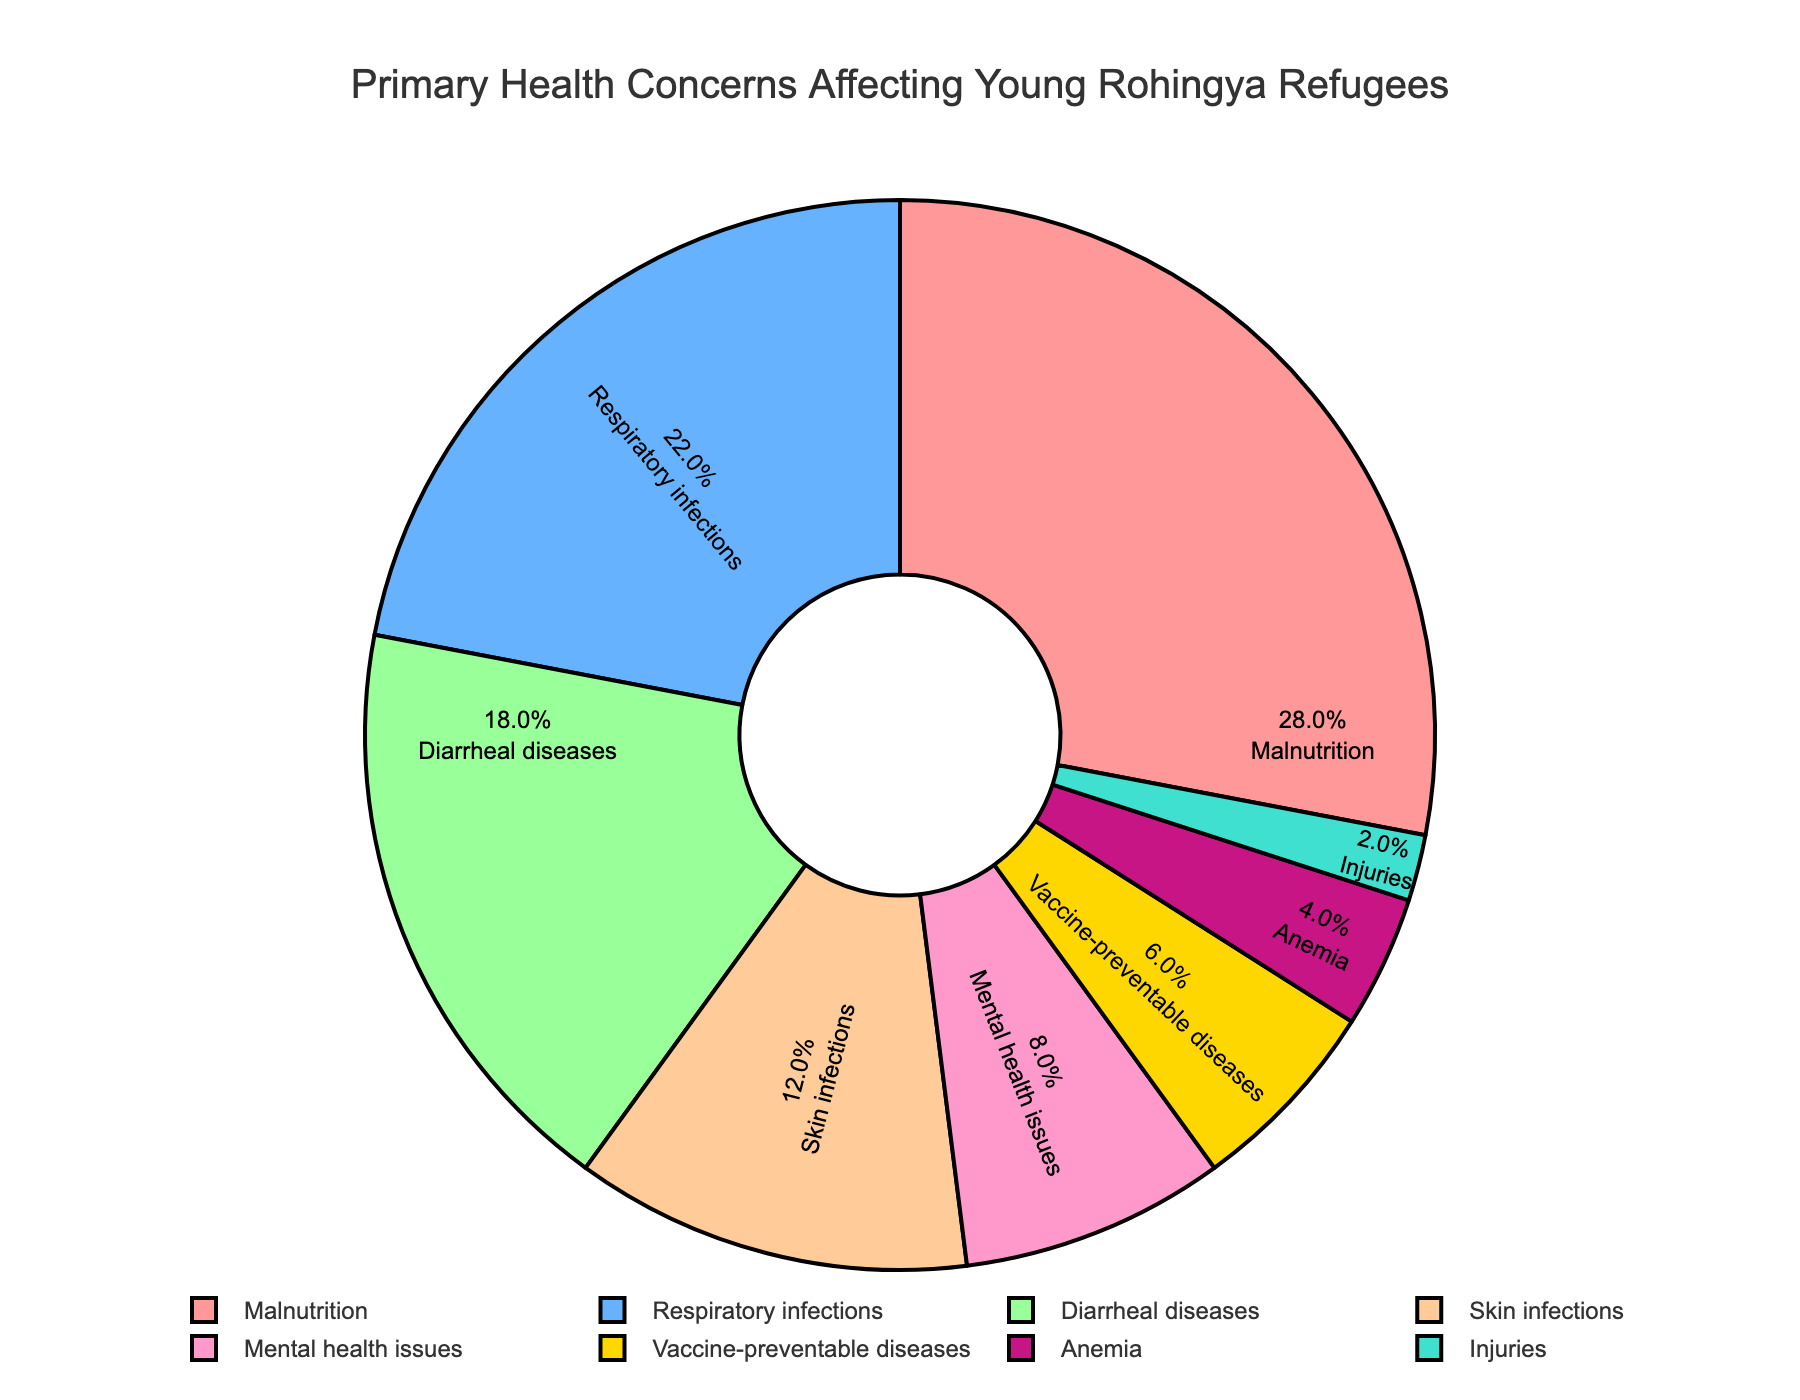What is the most common health concern affecting young Rohingya refugees? To find the most common health concern, look for the largest percentage slice in the pie chart. The 'Malnutrition' slice is the largest at 28%.
Answer: Malnutrition How does the percentage of respiratory infections compare to vaccine-preventable diseases? Identify the slices labeled 'Respiratory infections' and 'Vaccine-preventable diseases' in the pie chart. Respiratory infections have a larger slice (22%) compared to vaccine-preventable diseases (6%).
Answer: Respiratory infections are higher Which health concern is represented by the smallest slice on the pie chart? Locate the smallest slice on the pie chart, which represents 2%. This slice is labeled 'Injuries'.
Answer: Injuries What is the combined percentage of malnutrition and respiratory infections? Add the percentages of malnutrition (28%) and respiratory infections (22%). 28% + 22% = 50%.
Answer: 50% Are there more children affected by diarrheal diseases or mental health issues according to the pie chart? Compare the 'Diarrheal diseases' slice (18%) and the 'Mental health issues' slice (8%). Diarrheal diseases have a larger percentage.
Answer: Diarrheal diseases Which health concern affecting young Rohingya refugees accounts for twice as much as mental health issues? Mental health issues are at 8%. The health concern that accounts for twice this percentage is 16%. Diarrheal diseases are close with 18%, so they account for more than twice.
Answer: Diarrheal diseases What percentage of young Rohingya refugees are affected by skin infections? Identify the 'Skin infections' slice in the pie chart, which is labeled with the percentage 12%.
Answer: 12% By how much is the percentage of vaccine-preventable diseases less than mental health issues? Subtract the percentage of vaccine-preventable diseases (6%) from mental health issues (8%). 8% - 6% = 2%.
Answer: 2% What is the total percentage covered by respiratory infections, skin infections, and anemia? Add the percentages of respiratory infections (22%), skin infections (12%), and anemia (4%). 22% + 12% + 4% = 38%.
Answer: 38% Which two health concerns combined have the same proportion as malnutrition? Find two health concerns whose percentages add up to 28% (the percentage for malnutrition). Respiratory infections (22%) and vaccine-preventable diseases (6%) sum up to 28%.
Answer: Respiratory infections and vaccine-preventable diseases 